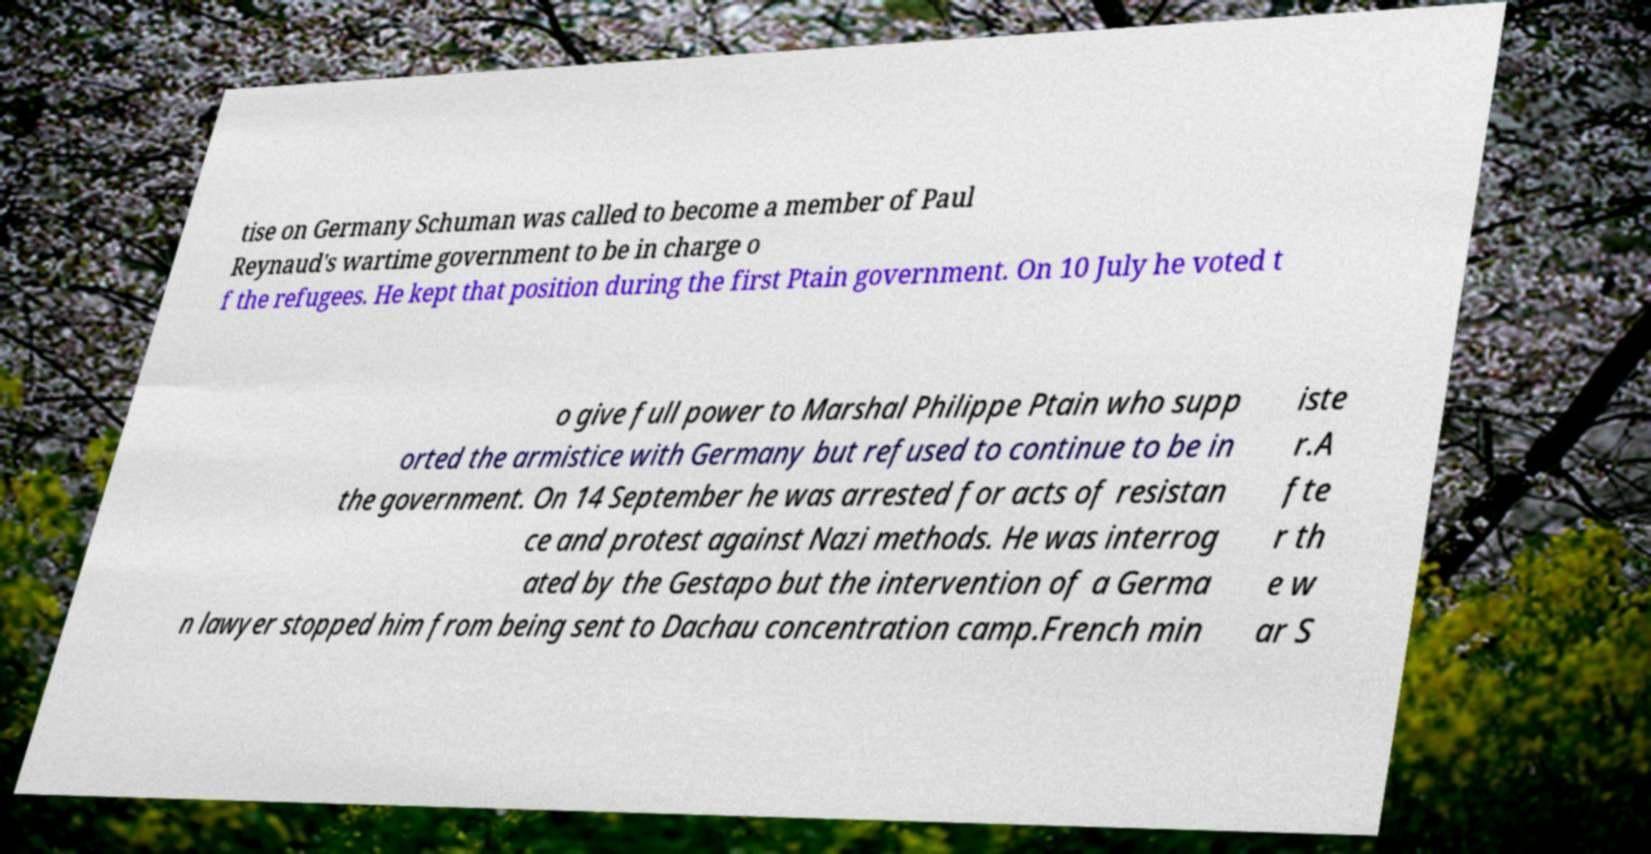Please identify and transcribe the text found in this image. tise on Germany Schuman was called to become a member of Paul Reynaud's wartime government to be in charge o f the refugees. He kept that position during the first Ptain government. On 10 July he voted t o give full power to Marshal Philippe Ptain who supp orted the armistice with Germany but refused to continue to be in the government. On 14 September he was arrested for acts of resistan ce and protest against Nazi methods. He was interrog ated by the Gestapo but the intervention of a Germa n lawyer stopped him from being sent to Dachau concentration camp.French min iste r.A fte r th e w ar S 